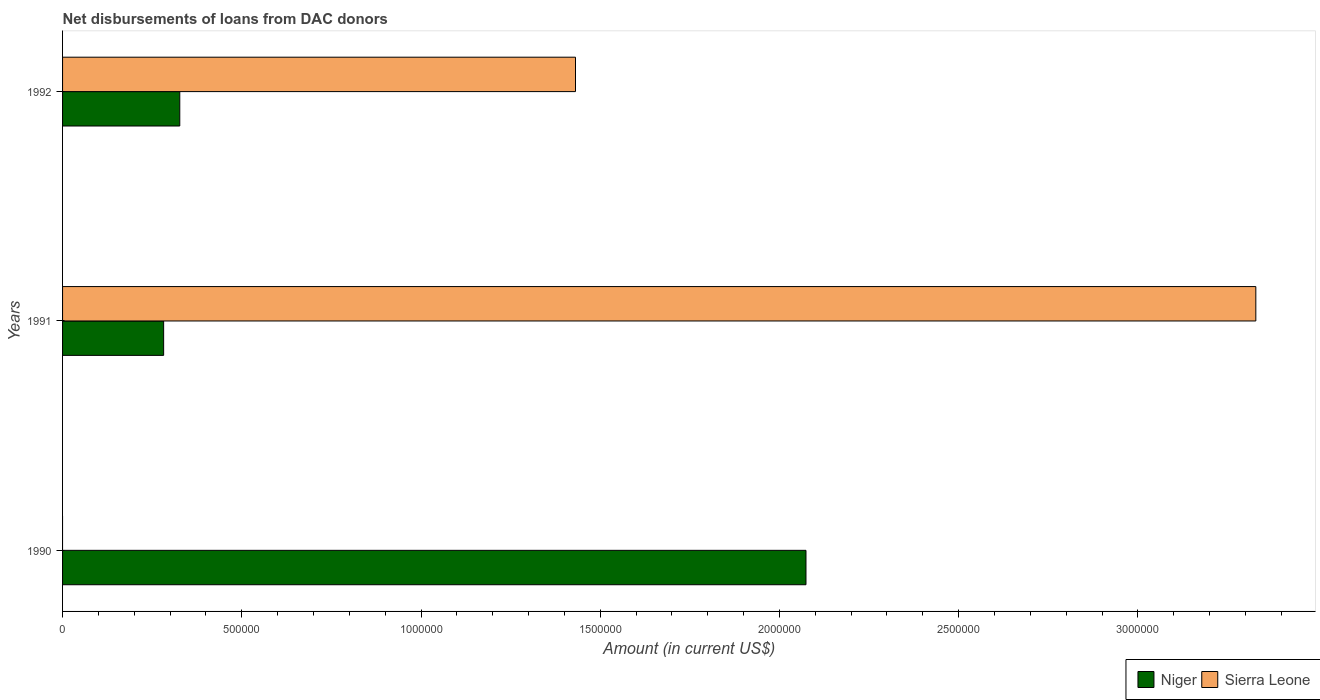How many bars are there on the 2nd tick from the bottom?
Offer a very short reply. 2. What is the label of the 1st group of bars from the top?
Your answer should be very brief. 1992. In how many cases, is the number of bars for a given year not equal to the number of legend labels?
Your response must be concise. 1. What is the amount of loans disbursed in Niger in 1990?
Your response must be concise. 2.07e+06. Across all years, what is the maximum amount of loans disbursed in Sierra Leone?
Keep it short and to the point. 3.33e+06. Across all years, what is the minimum amount of loans disbursed in Niger?
Give a very brief answer. 2.82e+05. In which year was the amount of loans disbursed in Sierra Leone maximum?
Offer a terse response. 1991. What is the total amount of loans disbursed in Sierra Leone in the graph?
Provide a short and direct response. 4.76e+06. What is the difference between the amount of loans disbursed in Niger in 1991 and that in 1992?
Offer a very short reply. -4.50e+04. What is the difference between the amount of loans disbursed in Niger in 1992 and the amount of loans disbursed in Sierra Leone in 1991?
Your answer should be compact. -3.00e+06. What is the average amount of loans disbursed in Sierra Leone per year?
Your answer should be very brief. 1.59e+06. In the year 1992, what is the difference between the amount of loans disbursed in Sierra Leone and amount of loans disbursed in Niger?
Ensure brevity in your answer.  1.10e+06. In how many years, is the amount of loans disbursed in Sierra Leone greater than 1600000 US$?
Provide a short and direct response. 1. What is the ratio of the amount of loans disbursed in Niger in 1991 to that in 1992?
Your answer should be very brief. 0.86. Is the difference between the amount of loans disbursed in Sierra Leone in 1991 and 1992 greater than the difference between the amount of loans disbursed in Niger in 1991 and 1992?
Your answer should be very brief. Yes. What is the difference between the highest and the second highest amount of loans disbursed in Niger?
Offer a very short reply. 1.75e+06. What is the difference between the highest and the lowest amount of loans disbursed in Niger?
Your response must be concise. 1.79e+06. In how many years, is the amount of loans disbursed in Niger greater than the average amount of loans disbursed in Niger taken over all years?
Give a very brief answer. 1. Is the sum of the amount of loans disbursed in Niger in 1990 and 1992 greater than the maximum amount of loans disbursed in Sierra Leone across all years?
Give a very brief answer. No. How many bars are there?
Your response must be concise. 5. How many years are there in the graph?
Offer a terse response. 3. What is the difference between two consecutive major ticks on the X-axis?
Keep it short and to the point. 5.00e+05. Are the values on the major ticks of X-axis written in scientific E-notation?
Offer a terse response. No. Does the graph contain any zero values?
Provide a short and direct response. Yes. Does the graph contain grids?
Offer a very short reply. No. How many legend labels are there?
Offer a terse response. 2. What is the title of the graph?
Your response must be concise. Net disbursements of loans from DAC donors. What is the label or title of the X-axis?
Provide a short and direct response. Amount (in current US$). What is the Amount (in current US$) of Niger in 1990?
Offer a terse response. 2.07e+06. What is the Amount (in current US$) of Niger in 1991?
Your response must be concise. 2.82e+05. What is the Amount (in current US$) in Sierra Leone in 1991?
Give a very brief answer. 3.33e+06. What is the Amount (in current US$) in Niger in 1992?
Make the answer very short. 3.27e+05. What is the Amount (in current US$) of Sierra Leone in 1992?
Ensure brevity in your answer.  1.43e+06. Across all years, what is the maximum Amount (in current US$) of Niger?
Offer a terse response. 2.07e+06. Across all years, what is the maximum Amount (in current US$) of Sierra Leone?
Provide a succinct answer. 3.33e+06. Across all years, what is the minimum Amount (in current US$) of Niger?
Your answer should be compact. 2.82e+05. Across all years, what is the minimum Amount (in current US$) of Sierra Leone?
Ensure brevity in your answer.  0. What is the total Amount (in current US$) in Niger in the graph?
Ensure brevity in your answer.  2.68e+06. What is the total Amount (in current US$) of Sierra Leone in the graph?
Your answer should be compact. 4.76e+06. What is the difference between the Amount (in current US$) in Niger in 1990 and that in 1991?
Ensure brevity in your answer.  1.79e+06. What is the difference between the Amount (in current US$) of Niger in 1990 and that in 1992?
Provide a succinct answer. 1.75e+06. What is the difference between the Amount (in current US$) of Niger in 1991 and that in 1992?
Provide a short and direct response. -4.50e+04. What is the difference between the Amount (in current US$) in Sierra Leone in 1991 and that in 1992?
Give a very brief answer. 1.90e+06. What is the difference between the Amount (in current US$) in Niger in 1990 and the Amount (in current US$) in Sierra Leone in 1991?
Offer a very short reply. -1.26e+06. What is the difference between the Amount (in current US$) in Niger in 1990 and the Amount (in current US$) in Sierra Leone in 1992?
Your response must be concise. 6.43e+05. What is the difference between the Amount (in current US$) in Niger in 1991 and the Amount (in current US$) in Sierra Leone in 1992?
Offer a very short reply. -1.15e+06. What is the average Amount (in current US$) of Niger per year?
Provide a short and direct response. 8.94e+05. What is the average Amount (in current US$) of Sierra Leone per year?
Your answer should be compact. 1.59e+06. In the year 1991, what is the difference between the Amount (in current US$) in Niger and Amount (in current US$) in Sierra Leone?
Your answer should be very brief. -3.05e+06. In the year 1992, what is the difference between the Amount (in current US$) in Niger and Amount (in current US$) in Sierra Leone?
Offer a very short reply. -1.10e+06. What is the ratio of the Amount (in current US$) in Niger in 1990 to that in 1991?
Your answer should be very brief. 7.35. What is the ratio of the Amount (in current US$) in Niger in 1990 to that in 1992?
Make the answer very short. 6.34. What is the ratio of the Amount (in current US$) in Niger in 1991 to that in 1992?
Your answer should be very brief. 0.86. What is the ratio of the Amount (in current US$) of Sierra Leone in 1991 to that in 1992?
Keep it short and to the point. 2.33. What is the difference between the highest and the second highest Amount (in current US$) in Niger?
Your answer should be very brief. 1.75e+06. What is the difference between the highest and the lowest Amount (in current US$) in Niger?
Keep it short and to the point. 1.79e+06. What is the difference between the highest and the lowest Amount (in current US$) of Sierra Leone?
Your answer should be compact. 3.33e+06. 